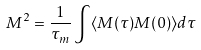Convert formula to latex. <formula><loc_0><loc_0><loc_500><loc_500>M ^ { 2 } = \frac { 1 } { \tau _ { m } } \int \langle M ( \tau ) M ( 0 ) \rangle d \tau</formula> 